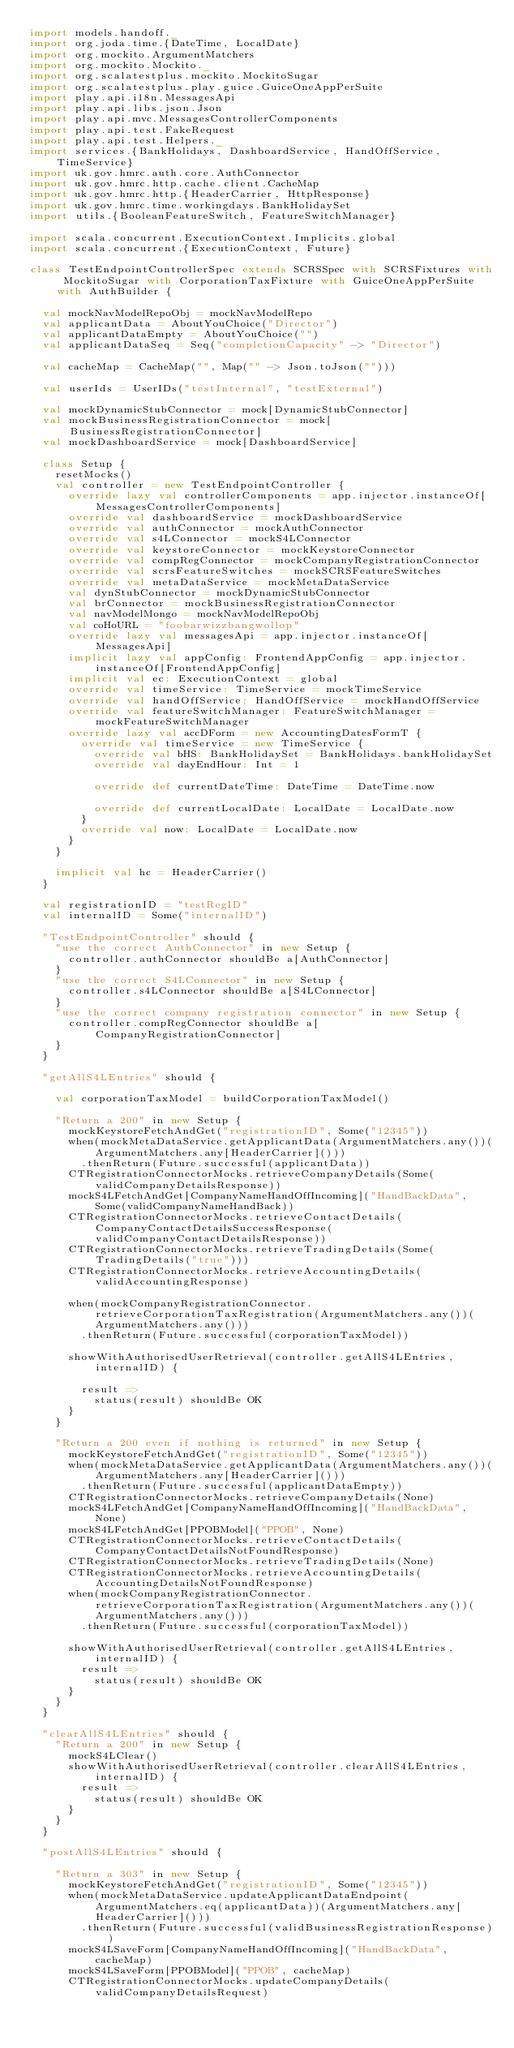<code> <loc_0><loc_0><loc_500><loc_500><_Scala_>import models.handoff._
import org.joda.time.{DateTime, LocalDate}
import org.mockito.ArgumentMatchers
import org.mockito.Mockito._
import org.scalatestplus.mockito.MockitoSugar
import org.scalatestplus.play.guice.GuiceOneAppPerSuite
import play.api.i18n.MessagesApi
import play.api.libs.json.Json
import play.api.mvc.MessagesControllerComponents
import play.api.test.FakeRequest
import play.api.test.Helpers._
import services.{BankHolidays, DashboardService, HandOffService, TimeService}
import uk.gov.hmrc.auth.core.AuthConnector
import uk.gov.hmrc.http.cache.client.CacheMap
import uk.gov.hmrc.http.{HeaderCarrier, HttpResponse}
import uk.gov.hmrc.time.workingdays.BankHolidaySet
import utils.{BooleanFeatureSwitch, FeatureSwitchManager}

import scala.concurrent.ExecutionContext.Implicits.global
import scala.concurrent.{ExecutionContext, Future}

class TestEndpointControllerSpec extends SCRSSpec with SCRSFixtures with MockitoSugar with CorporationTaxFixture with GuiceOneAppPerSuite with AuthBuilder {

  val mockNavModelRepoObj = mockNavModelRepo
  val applicantData = AboutYouChoice("Director")
  val applicantDataEmpty = AboutYouChoice("")
  val applicantDataSeq = Seq("completionCapacity" -> "Director")

  val cacheMap = CacheMap("", Map("" -> Json.toJson("")))

  val userIds = UserIDs("testInternal", "testExternal")

  val mockDynamicStubConnector = mock[DynamicStubConnector]
  val mockBusinessRegistrationConnector = mock[BusinessRegistrationConnector]
  val mockDashboardService = mock[DashboardService]

  class Setup {
    resetMocks()
    val controller = new TestEndpointController {
      override lazy val controllerComponents = app.injector.instanceOf[MessagesControllerComponents]
      override val dashboardService = mockDashboardService
      override val authConnector = mockAuthConnector
      override val s4LConnector = mockS4LConnector
      override val keystoreConnector = mockKeystoreConnector
      override val compRegConnector = mockCompanyRegistrationConnector
      override val scrsFeatureSwitches = mockSCRSFeatureSwitches
      override val metaDataService = mockMetaDataService
      val dynStubConnector = mockDynamicStubConnector
      val brConnector = mockBusinessRegistrationConnector
      val navModelMongo = mockNavModelRepoObj
      val coHoURL = "foobarwizzbangwollop"
      override lazy val messagesApi = app.injector.instanceOf[MessagesApi]
      implicit lazy val appConfig: FrontendAppConfig = app.injector.instanceOf[FrontendAppConfig]
      implicit val ec: ExecutionContext = global
      override val timeService: TimeService = mockTimeService
      override val handOffService: HandOffService = mockHandOffService
      override val featureSwitchManager: FeatureSwitchManager = mockFeatureSwitchManager
      override lazy val accDForm = new AccountingDatesFormT {
        override val timeService = new TimeService {
          override val bHS: BankHolidaySet = BankHolidays.bankHolidaySet
          override val dayEndHour: Int = 1

          override def currentDateTime: DateTime = DateTime.now

          override def currentLocalDate: LocalDate = LocalDate.now
        }
        override val now: LocalDate = LocalDate.now
      }
    }

    implicit val hc = HeaderCarrier()
  }

  val registrationID = "testRegID"
  val internalID = Some("internalID")

  "TestEndpointController" should {
    "use the correct AuthConnector" in new Setup {
      controller.authConnector shouldBe a[AuthConnector]
    }
    "use the correct S4LConnector" in new Setup {
      controller.s4LConnector shouldBe a[S4LConnector]
    }
    "use the correct company registration connector" in new Setup {
      controller.compRegConnector shouldBe a[CompanyRegistrationConnector]
    }
  }

  "getAllS4LEntries" should {

    val corporationTaxModel = buildCorporationTaxModel()

    "Return a 200" in new Setup {
      mockKeystoreFetchAndGet("registrationID", Some("12345"))
      when(mockMetaDataService.getApplicantData(ArgumentMatchers.any())(ArgumentMatchers.any[HeaderCarrier]()))
        .thenReturn(Future.successful(applicantData))
      CTRegistrationConnectorMocks.retrieveCompanyDetails(Some(validCompanyDetailsResponse))
      mockS4LFetchAndGet[CompanyNameHandOffIncoming]("HandBackData", Some(validCompanyNameHandBack))
      CTRegistrationConnectorMocks.retrieveContactDetails(CompanyContactDetailsSuccessResponse(validCompanyContactDetailsResponse))
      CTRegistrationConnectorMocks.retrieveTradingDetails(Some(TradingDetails("true")))
      CTRegistrationConnectorMocks.retrieveAccountingDetails(validAccountingResponse)

      when(mockCompanyRegistrationConnector.retrieveCorporationTaxRegistration(ArgumentMatchers.any())(ArgumentMatchers.any()))
        .thenReturn(Future.successful(corporationTaxModel))

      showWithAuthorisedUserRetrieval(controller.getAllS4LEntries, internalID) {

        result =>
          status(result) shouldBe OK
      }
    }

    "Return a 200 even if nothing is returned" in new Setup {
      mockKeystoreFetchAndGet("registrationID", Some("12345"))
      when(mockMetaDataService.getApplicantData(ArgumentMatchers.any())(ArgumentMatchers.any[HeaderCarrier]()))
        .thenReturn(Future.successful(applicantDataEmpty))
      CTRegistrationConnectorMocks.retrieveCompanyDetails(None)
      mockS4LFetchAndGet[CompanyNameHandOffIncoming]("HandBackData", None)
      mockS4LFetchAndGet[PPOBModel]("PPOB", None)
      CTRegistrationConnectorMocks.retrieveContactDetails(CompanyContactDetailsNotFoundResponse)
      CTRegistrationConnectorMocks.retrieveTradingDetails(None)
      CTRegistrationConnectorMocks.retrieveAccountingDetails(AccountingDetailsNotFoundResponse)
      when(mockCompanyRegistrationConnector.retrieveCorporationTaxRegistration(ArgumentMatchers.any())(ArgumentMatchers.any()))
        .thenReturn(Future.successful(corporationTaxModel))

      showWithAuthorisedUserRetrieval(controller.getAllS4LEntries, internalID) {
        result =>
          status(result) shouldBe OK
      }
    }
  }

  "clearAllS4LEntries" should {
    "Return a 200" in new Setup {
      mockS4LClear()
      showWithAuthorisedUserRetrieval(controller.clearAllS4LEntries, internalID) {
        result =>
          status(result) shouldBe OK
      }
    }
  }

  "postAllS4LEntries" should {

    "Return a 303" in new Setup {
      mockKeystoreFetchAndGet("registrationID", Some("12345"))
      when(mockMetaDataService.updateApplicantDataEndpoint(ArgumentMatchers.eq(applicantData))(ArgumentMatchers.any[HeaderCarrier]()))
        .thenReturn(Future.successful(validBusinessRegistrationResponse))
      mockS4LSaveForm[CompanyNameHandOffIncoming]("HandBackData", cacheMap)
      mockS4LSaveForm[PPOBModel]("PPOB", cacheMap)
      CTRegistrationConnectorMocks.updateCompanyDetails(validCompanyDetailsRequest)</code> 